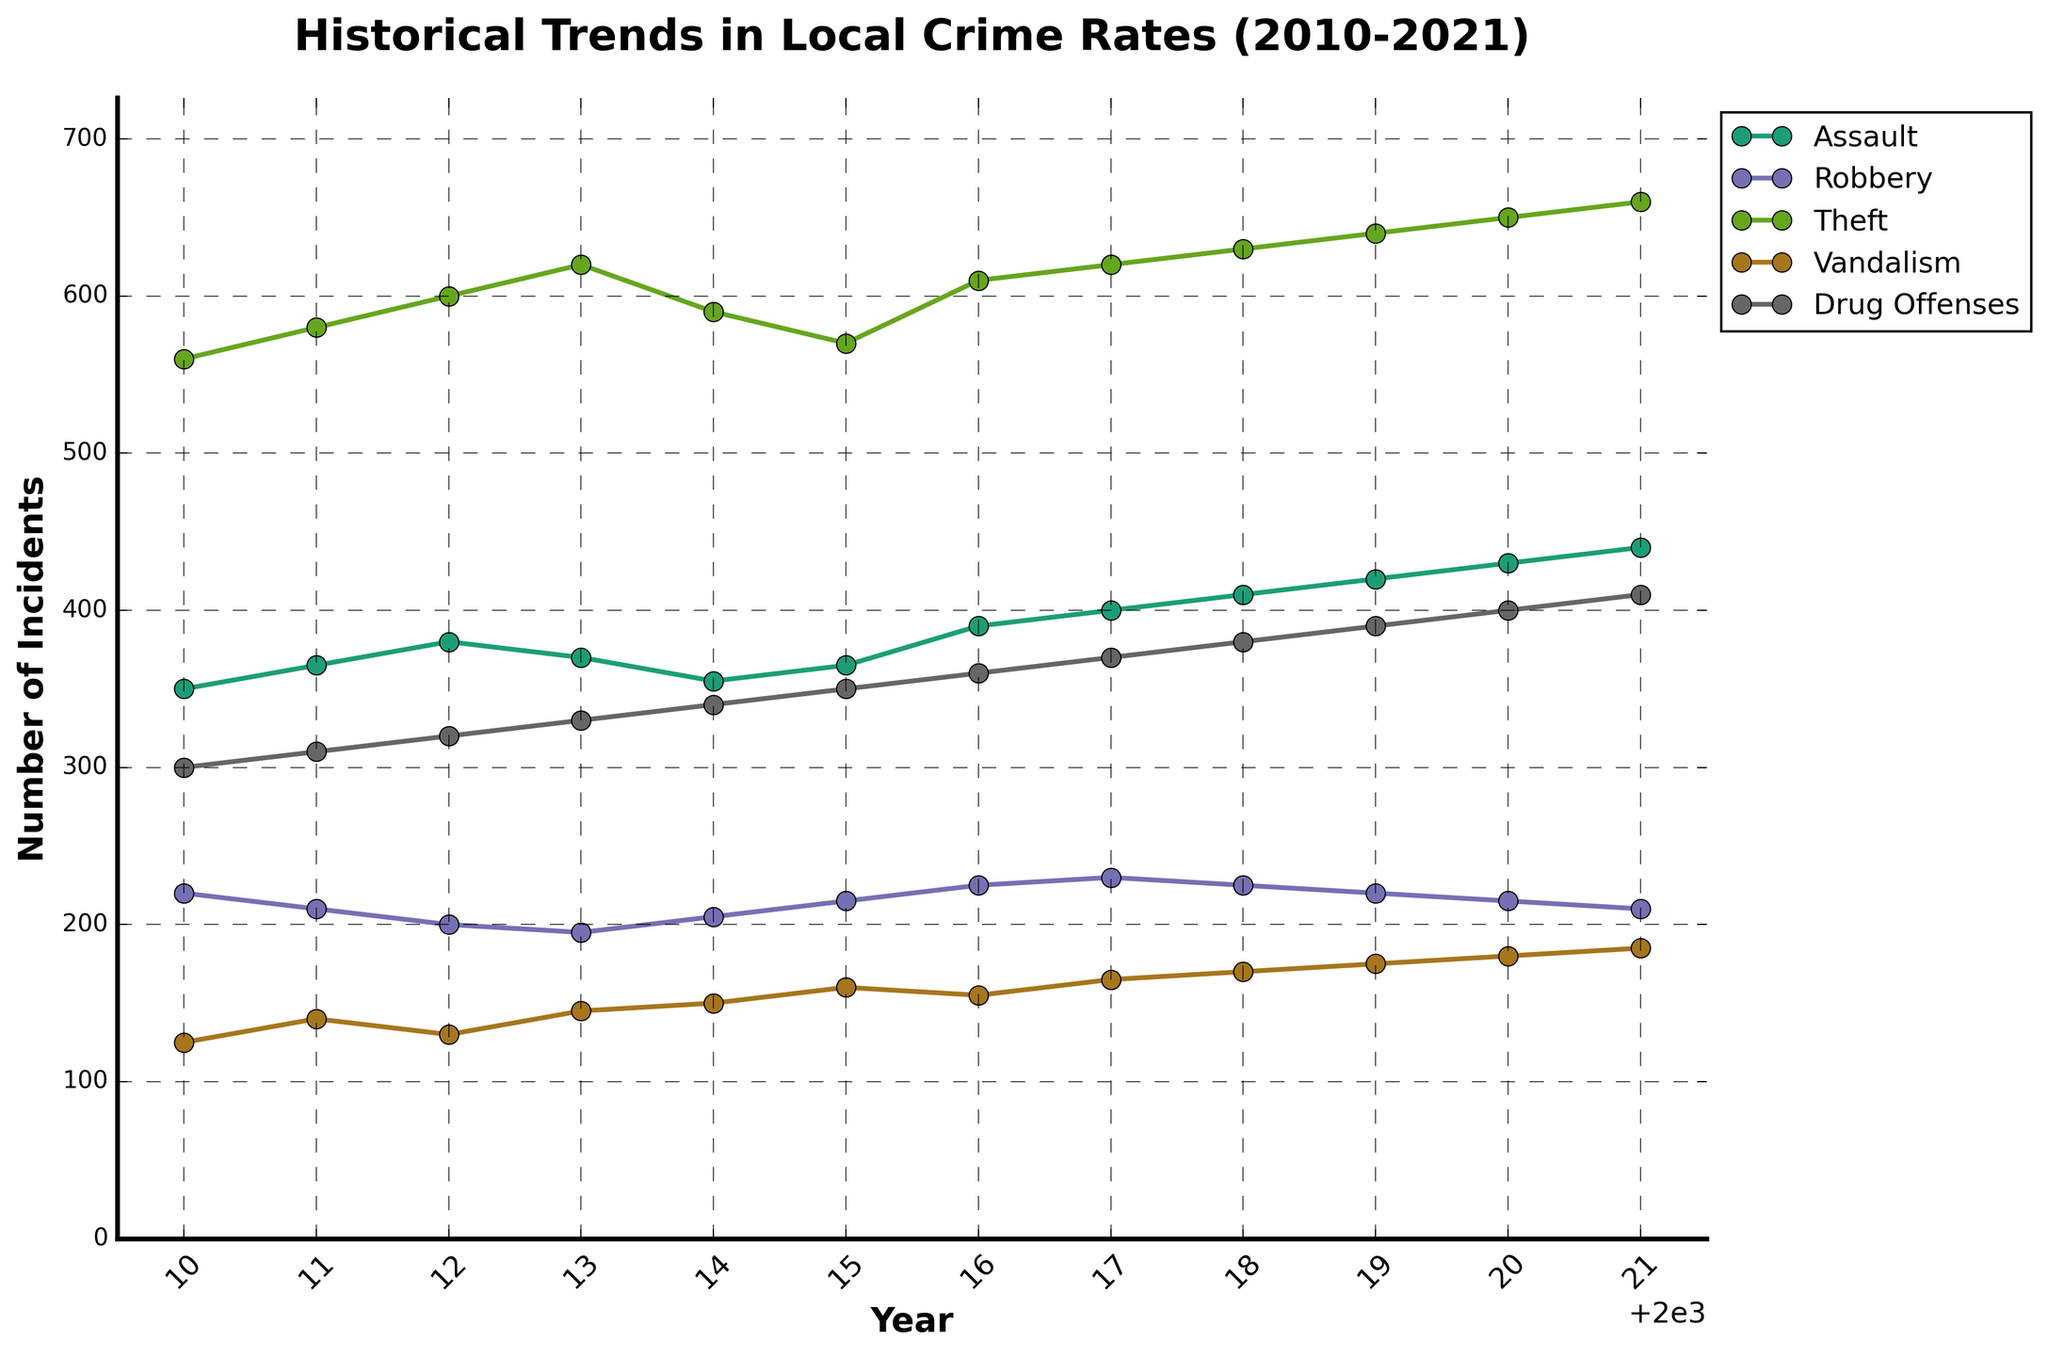What is the overall title of the figure? The overall title of the figure is located at the top center of the plot. It reads "Historical Trends in Local Crime Rates (2010-2021)."
Answer: Historical Trends in Local Crime Rates (2010-2021) What are the labels on the x-axis and y-axis? The x-axis label reads "Year" and the y-axis label reads "Number of Incidents." These labels indicate that years are on the x-axis and the number of incidents is on the y-axis.
Answer: Year (x-axis) and Number of Incidents (y-axis) Which type of crime had the highest number of incidents in 2010? To find this, observe the data points for the year 2010 across all crime types. The lines correspond to each type of crime, and the one with the highest y-value in 2010 is Theft.
Answer: Theft What was the trend in the number of Assault incidents from 2010 to 2021? By following the color-coded line for Assault on the plot, we can observe the number of incidents year by year. The trend shows an increase in Assault incidents from 350 in 2010 to 440 in 2021.
Answer: Increasing Between which years did Drug Offenses see the most significant increase in incidents? To determine this, examine the line for Drug Offenses and identify the steepest incline. The most significant increase occurred between 2015 (350 incidents) and 2016 (360 incidents).
Answer: 2015 to 2016 Which type of crime demonstrates the most steady trend over the years? By comparing the trends of all crime types, observe that Robbery shows relatively small fluctuations over the years compared to others, indicating a more steady trend.
Answer: Robbery How many total incidents of Vandalism occurred in 2018 and 2019 combined? Sum the number of incidents of Vandalism for the two years: 170 (2018) + 175 (2019) = 345.
Answer: 345 Among Theft and Robbery, which type of crime had a higher number of incidents in 2015, and by how much? Compare the 2015 values for Theft (570) and Robbery (215). Theft had more incidents than Robbery. The difference is 570 - 215 = 355.
Answer: Theft by 355 incidents What is the average number of Vandalism incidents from 2010 to 2021? Sum the number of Vandalism incidents for all years and divide by the number of years. (125 + 140 + 130 + 145 + 150 + 160 + 155 + 165 + 170 + 175 + 180 + 185) / 12 = 1645 / 12 = 137.08
Answer: 137.08 